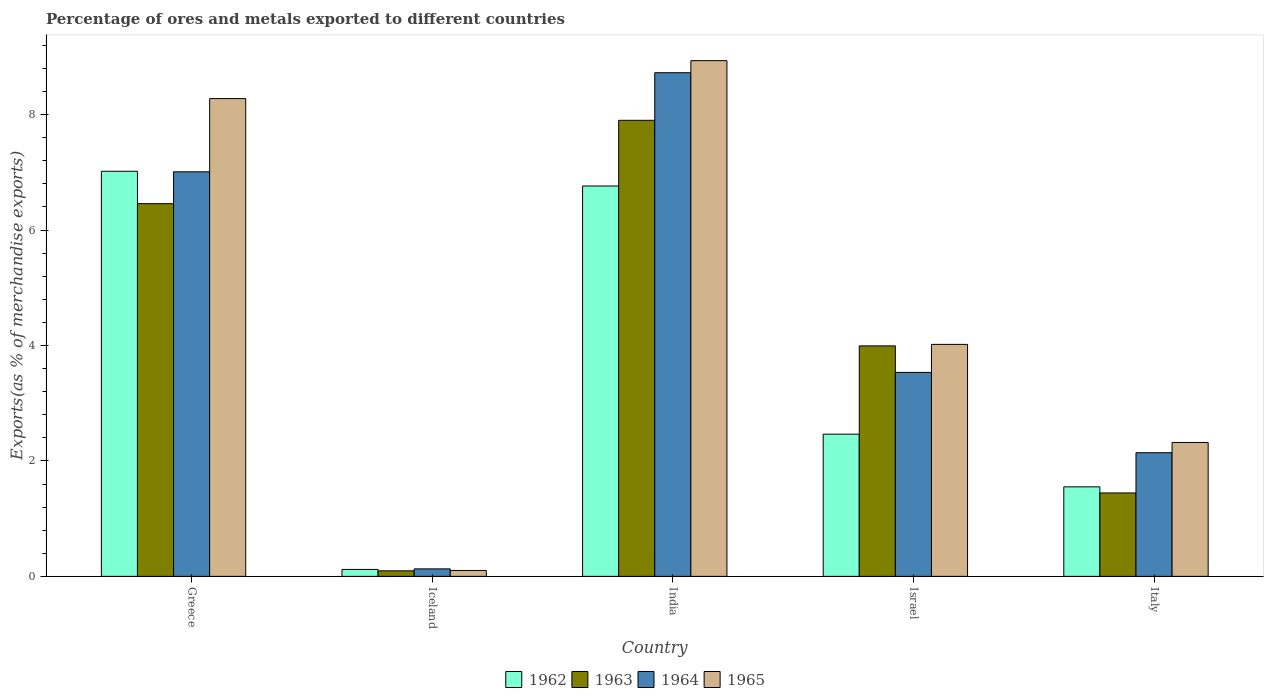How many different coloured bars are there?
Provide a short and direct response. 4. Are the number of bars per tick equal to the number of legend labels?
Your response must be concise. Yes. How many bars are there on the 4th tick from the left?
Your response must be concise. 4. How many bars are there on the 3rd tick from the right?
Offer a very short reply. 4. What is the label of the 1st group of bars from the left?
Offer a terse response. Greece. What is the percentage of exports to different countries in 1962 in Greece?
Offer a very short reply. 7.02. Across all countries, what is the maximum percentage of exports to different countries in 1965?
Make the answer very short. 8.94. Across all countries, what is the minimum percentage of exports to different countries in 1962?
Your response must be concise. 0.12. In which country was the percentage of exports to different countries in 1963 minimum?
Provide a succinct answer. Iceland. What is the total percentage of exports to different countries in 1964 in the graph?
Keep it short and to the point. 21.54. What is the difference between the percentage of exports to different countries in 1963 in Iceland and that in Israel?
Make the answer very short. -3.9. What is the difference between the percentage of exports to different countries in 1963 in Iceland and the percentage of exports to different countries in 1964 in Greece?
Your response must be concise. -6.91. What is the average percentage of exports to different countries in 1963 per country?
Offer a terse response. 3.98. What is the difference between the percentage of exports to different countries of/in 1963 and percentage of exports to different countries of/in 1965 in India?
Make the answer very short. -1.03. What is the ratio of the percentage of exports to different countries in 1962 in India to that in Italy?
Provide a succinct answer. 4.36. Is the percentage of exports to different countries in 1962 in Iceland less than that in Italy?
Offer a terse response. Yes. Is the difference between the percentage of exports to different countries in 1963 in Greece and Israel greater than the difference between the percentage of exports to different countries in 1965 in Greece and Israel?
Your answer should be very brief. No. What is the difference between the highest and the second highest percentage of exports to different countries in 1962?
Offer a very short reply. -4.3. What is the difference between the highest and the lowest percentage of exports to different countries in 1964?
Your answer should be compact. 8.6. Is the sum of the percentage of exports to different countries in 1963 in India and Italy greater than the maximum percentage of exports to different countries in 1965 across all countries?
Ensure brevity in your answer.  Yes. Is it the case that in every country, the sum of the percentage of exports to different countries in 1963 and percentage of exports to different countries in 1964 is greater than the sum of percentage of exports to different countries in 1962 and percentage of exports to different countries in 1965?
Offer a terse response. No. What does the 2nd bar from the right in Iceland represents?
Your response must be concise. 1964. How many bars are there?
Provide a short and direct response. 20. Are the values on the major ticks of Y-axis written in scientific E-notation?
Ensure brevity in your answer.  No. Where does the legend appear in the graph?
Your response must be concise. Bottom center. How many legend labels are there?
Your response must be concise. 4. What is the title of the graph?
Your answer should be compact. Percentage of ores and metals exported to different countries. Does "1964" appear as one of the legend labels in the graph?
Your answer should be compact. Yes. What is the label or title of the Y-axis?
Offer a very short reply. Exports(as % of merchandise exports). What is the Exports(as % of merchandise exports) of 1962 in Greece?
Your response must be concise. 7.02. What is the Exports(as % of merchandise exports) of 1963 in Greece?
Your response must be concise. 6.46. What is the Exports(as % of merchandise exports) of 1964 in Greece?
Offer a terse response. 7.01. What is the Exports(as % of merchandise exports) of 1965 in Greece?
Make the answer very short. 8.28. What is the Exports(as % of merchandise exports) of 1962 in Iceland?
Keep it short and to the point. 0.12. What is the Exports(as % of merchandise exports) of 1963 in Iceland?
Make the answer very short. 0.1. What is the Exports(as % of merchandise exports) of 1964 in Iceland?
Offer a very short reply. 0.13. What is the Exports(as % of merchandise exports) of 1965 in Iceland?
Offer a very short reply. 0.1. What is the Exports(as % of merchandise exports) of 1962 in India?
Provide a succinct answer. 6.76. What is the Exports(as % of merchandise exports) in 1963 in India?
Keep it short and to the point. 7.9. What is the Exports(as % of merchandise exports) in 1964 in India?
Keep it short and to the point. 8.73. What is the Exports(as % of merchandise exports) of 1965 in India?
Offer a terse response. 8.94. What is the Exports(as % of merchandise exports) in 1962 in Israel?
Provide a short and direct response. 2.46. What is the Exports(as % of merchandise exports) of 1963 in Israel?
Give a very brief answer. 3.99. What is the Exports(as % of merchandise exports) in 1964 in Israel?
Offer a very short reply. 3.53. What is the Exports(as % of merchandise exports) in 1965 in Israel?
Ensure brevity in your answer.  4.02. What is the Exports(as % of merchandise exports) of 1962 in Italy?
Offer a terse response. 1.55. What is the Exports(as % of merchandise exports) in 1963 in Italy?
Ensure brevity in your answer.  1.45. What is the Exports(as % of merchandise exports) in 1964 in Italy?
Your answer should be very brief. 2.14. What is the Exports(as % of merchandise exports) of 1965 in Italy?
Your answer should be very brief. 2.32. Across all countries, what is the maximum Exports(as % of merchandise exports) of 1962?
Provide a succinct answer. 7.02. Across all countries, what is the maximum Exports(as % of merchandise exports) of 1963?
Keep it short and to the point. 7.9. Across all countries, what is the maximum Exports(as % of merchandise exports) of 1964?
Provide a succinct answer. 8.73. Across all countries, what is the maximum Exports(as % of merchandise exports) of 1965?
Provide a short and direct response. 8.94. Across all countries, what is the minimum Exports(as % of merchandise exports) of 1962?
Provide a succinct answer. 0.12. Across all countries, what is the minimum Exports(as % of merchandise exports) in 1963?
Provide a succinct answer. 0.1. Across all countries, what is the minimum Exports(as % of merchandise exports) in 1964?
Offer a terse response. 0.13. Across all countries, what is the minimum Exports(as % of merchandise exports) of 1965?
Give a very brief answer. 0.1. What is the total Exports(as % of merchandise exports) of 1962 in the graph?
Your answer should be very brief. 17.92. What is the total Exports(as % of merchandise exports) of 1963 in the graph?
Ensure brevity in your answer.  19.89. What is the total Exports(as % of merchandise exports) of 1964 in the graph?
Give a very brief answer. 21.54. What is the total Exports(as % of merchandise exports) of 1965 in the graph?
Your answer should be very brief. 23.65. What is the difference between the Exports(as % of merchandise exports) of 1962 in Greece and that in Iceland?
Offer a terse response. 6.9. What is the difference between the Exports(as % of merchandise exports) in 1963 in Greece and that in Iceland?
Your response must be concise. 6.36. What is the difference between the Exports(as % of merchandise exports) of 1964 in Greece and that in Iceland?
Offer a terse response. 6.88. What is the difference between the Exports(as % of merchandise exports) in 1965 in Greece and that in Iceland?
Your answer should be very brief. 8.18. What is the difference between the Exports(as % of merchandise exports) in 1962 in Greece and that in India?
Keep it short and to the point. 0.26. What is the difference between the Exports(as % of merchandise exports) in 1963 in Greece and that in India?
Provide a succinct answer. -1.44. What is the difference between the Exports(as % of merchandise exports) of 1964 in Greece and that in India?
Ensure brevity in your answer.  -1.72. What is the difference between the Exports(as % of merchandise exports) of 1965 in Greece and that in India?
Make the answer very short. -0.66. What is the difference between the Exports(as % of merchandise exports) of 1962 in Greece and that in Israel?
Ensure brevity in your answer.  4.55. What is the difference between the Exports(as % of merchandise exports) of 1963 in Greece and that in Israel?
Ensure brevity in your answer.  2.46. What is the difference between the Exports(as % of merchandise exports) of 1964 in Greece and that in Israel?
Keep it short and to the point. 3.48. What is the difference between the Exports(as % of merchandise exports) of 1965 in Greece and that in Israel?
Ensure brevity in your answer.  4.26. What is the difference between the Exports(as % of merchandise exports) of 1962 in Greece and that in Italy?
Ensure brevity in your answer.  5.47. What is the difference between the Exports(as % of merchandise exports) in 1963 in Greece and that in Italy?
Offer a terse response. 5.01. What is the difference between the Exports(as % of merchandise exports) in 1964 in Greece and that in Italy?
Give a very brief answer. 4.87. What is the difference between the Exports(as % of merchandise exports) of 1965 in Greece and that in Italy?
Make the answer very short. 5.96. What is the difference between the Exports(as % of merchandise exports) of 1962 in Iceland and that in India?
Make the answer very short. -6.64. What is the difference between the Exports(as % of merchandise exports) of 1963 in Iceland and that in India?
Offer a very short reply. -7.81. What is the difference between the Exports(as % of merchandise exports) of 1964 in Iceland and that in India?
Offer a very short reply. -8.6. What is the difference between the Exports(as % of merchandise exports) in 1965 in Iceland and that in India?
Provide a succinct answer. -8.83. What is the difference between the Exports(as % of merchandise exports) of 1962 in Iceland and that in Israel?
Provide a short and direct response. -2.34. What is the difference between the Exports(as % of merchandise exports) of 1963 in Iceland and that in Israel?
Offer a very short reply. -3.9. What is the difference between the Exports(as % of merchandise exports) of 1964 in Iceland and that in Israel?
Offer a very short reply. -3.4. What is the difference between the Exports(as % of merchandise exports) in 1965 in Iceland and that in Israel?
Provide a short and direct response. -3.92. What is the difference between the Exports(as % of merchandise exports) of 1962 in Iceland and that in Italy?
Your answer should be very brief. -1.43. What is the difference between the Exports(as % of merchandise exports) in 1963 in Iceland and that in Italy?
Provide a succinct answer. -1.35. What is the difference between the Exports(as % of merchandise exports) in 1964 in Iceland and that in Italy?
Offer a very short reply. -2.01. What is the difference between the Exports(as % of merchandise exports) in 1965 in Iceland and that in Italy?
Your answer should be very brief. -2.22. What is the difference between the Exports(as % of merchandise exports) of 1962 in India and that in Israel?
Your answer should be very brief. 4.3. What is the difference between the Exports(as % of merchandise exports) of 1963 in India and that in Israel?
Give a very brief answer. 3.91. What is the difference between the Exports(as % of merchandise exports) of 1964 in India and that in Israel?
Offer a terse response. 5.19. What is the difference between the Exports(as % of merchandise exports) of 1965 in India and that in Israel?
Ensure brevity in your answer.  4.92. What is the difference between the Exports(as % of merchandise exports) in 1962 in India and that in Italy?
Ensure brevity in your answer.  5.21. What is the difference between the Exports(as % of merchandise exports) of 1963 in India and that in Italy?
Your answer should be compact. 6.46. What is the difference between the Exports(as % of merchandise exports) in 1964 in India and that in Italy?
Your response must be concise. 6.58. What is the difference between the Exports(as % of merchandise exports) of 1965 in India and that in Italy?
Your answer should be very brief. 6.62. What is the difference between the Exports(as % of merchandise exports) of 1962 in Israel and that in Italy?
Give a very brief answer. 0.91. What is the difference between the Exports(as % of merchandise exports) in 1963 in Israel and that in Italy?
Make the answer very short. 2.55. What is the difference between the Exports(as % of merchandise exports) of 1964 in Israel and that in Italy?
Your response must be concise. 1.39. What is the difference between the Exports(as % of merchandise exports) of 1965 in Israel and that in Italy?
Provide a short and direct response. 1.7. What is the difference between the Exports(as % of merchandise exports) of 1962 in Greece and the Exports(as % of merchandise exports) of 1963 in Iceland?
Provide a short and direct response. 6.92. What is the difference between the Exports(as % of merchandise exports) of 1962 in Greece and the Exports(as % of merchandise exports) of 1964 in Iceland?
Your answer should be very brief. 6.89. What is the difference between the Exports(as % of merchandise exports) in 1962 in Greece and the Exports(as % of merchandise exports) in 1965 in Iceland?
Give a very brief answer. 6.92. What is the difference between the Exports(as % of merchandise exports) in 1963 in Greece and the Exports(as % of merchandise exports) in 1964 in Iceland?
Keep it short and to the point. 6.33. What is the difference between the Exports(as % of merchandise exports) of 1963 in Greece and the Exports(as % of merchandise exports) of 1965 in Iceland?
Your response must be concise. 6.36. What is the difference between the Exports(as % of merchandise exports) of 1964 in Greece and the Exports(as % of merchandise exports) of 1965 in Iceland?
Provide a succinct answer. 6.91. What is the difference between the Exports(as % of merchandise exports) in 1962 in Greece and the Exports(as % of merchandise exports) in 1963 in India?
Give a very brief answer. -0.88. What is the difference between the Exports(as % of merchandise exports) of 1962 in Greece and the Exports(as % of merchandise exports) of 1964 in India?
Ensure brevity in your answer.  -1.71. What is the difference between the Exports(as % of merchandise exports) in 1962 in Greece and the Exports(as % of merchandise exports) in 1965 in India?
Ensure brevity in your answer.  -1.92. What is the difference between the Exports(as % of merchandise exports) in 1963 in Greece and the Exports(as % of merchandise exports) in 1964 in India?
Your answer should be compact. -2.27. What is the difference between the Exports(as % of merchandise exports) in 1963 in Greece and the Exports(as % of merchandise exports) in 1965 in India?
Your answer should be very brief. -2.48. What is the difference between the Exports(as % of merchandise exports) of 1964 in Greece and the Exports(as % of merchandise exports) of 1965 in India?
Keep it short and to the point. -1.93. What is the difference between the Exports(as % of merchandise exports) in 1962 in Greece and the Exports(as % of merchandise exports) in 1963 in Israel?
Provide a short and direct response. 3.03. What is the difference between the Exports(as % of merchandise exports) in 1962 in Greece and the Exports(as % of merchandise exports) in 1964 in Israel?
Provide a short and direct response. 3.48. What is the difference between the Exports(as % of merchandise exports) in 1962 in Greece and the Exports(as % of merchandise exports) in 1965 in Israel?
Your answer should be compact. 3. What is the difference between the Exports(as % of merchandise exports) in 1963 in Greece and the Exports(as % of merchandise exports) in 1964 in Israel?
Make the answer very short. 2.92. What is the difference between the Exports(as % of merchandise exports) of 1963 in Greece and the Exports(as % of merchandise exports) of 1965 in Israel?
Your answer should be compact. 2.44. What is the difference between the Exports(as % of merchandise exports) of 1964 in Greece and the Exports(as % of merchandise exports) of 1965 in Israel?
Ensure brevity in your answer.  2.99. What is the difference between the Exports(as % of merchandise exports) of 1962 in Greece and the Exports(as % of merchandise exports) of 1963 in Italy?
Ensure brevity in your answer.  5.57. What is the difference between the Exports(as % of merchandise exports) in 1962 in Greece and the Exports(as % of merchandise exports) in 1964 in Italy?
Provide a succinct answer. 4.88. What is the difference between the Exports(as % of merchandise exports) in 1962 in Greece and the Exports(as % of merchandise exports) in 1965 in Italy?
Make the answer very short. 4.7. What is the difference between the Exports(as % of merchandise exports) of 1963 in Greece and the Exports(as % of merchandise exports) of 1964 in Italy?
Your answer should be compact. 4.32. What is the difference between the Exports(as % of merchandise exports) in 1963 in Greece and the Exports(as % of merchandise exports) in 1965 in Italy?
Your answer should be compact. 4.14. What is the difference between the Exports(as % of merchandise exports) of 1964 in Greece and the Exports(as % of merchandise exports) of 1965 in Italy?
Offer a terse response. 4.69. What is the difference between the Exports(as % of merchandise exports) of 1962 in Iceland and the Exports(as % of merchandise exports) of 1963 in India?
Give a very brief answer. -7.78. What is the difference between the Exports(as % of merchandise exports) of 1962 in Iceland and the Exports(as % of merchandise exports) of 1964 in India?
Provide a short and direct response. -8.61. What is the difference between the Exports(as % of merchandise exports) of 1962 in Iceland and the Exports(as % of merchandise exports) of 1965 in India?
Make the answer very short. -8.82. What is the difference between the Exports(as % of merchandise exports) of 1963 in Iceland and the Exports(as % of merchandise exports) of 1964 in India?
Your answer should be very brief. -8.63. What is the difference between the Exports(as % of merchandise exports) of 1963 in Iceland and the Exports(as % of merchandise exports) of 1965 in India?
Provide a short and direct response. -8.84. What is the difference between the Exports(as % of merchandise exports) in 1964 in Iceland and the Exports(as % of merchandise exports) in 1965 in India?
Your answer should be very brief. -8.81. What is the difference between the Exports(as % of merchandise exports) in 1962 in Iceland and the Exports(as % of merchandise exports) in 1963 in Israel?
Give a very brief answer. -3.87. What is the difference between the Exports(as % of merchandise exports) of 1962 in Iceland and the Exports(as % of merchandise exports) of 1964 in Israel?
Offer a very short reply. -3.41. What is the difference between the Exports(as % of merchandise exports) in 1962 in Iceland and the Exports(as % of merchandise exports) in 1965 in Israel?
Ensure brevity in your answer.  -3.9. What is the difference between the Exports(as % of merchandise exports) in 1963 in Iceland and the Exports(as % of merchandise exports) in 1964 in Israel?
Give a very brief answer. -3.44. What is the difference between the Exports(as % of merchandise exports) of 1963 in Iceland and the Exports(as % of merchandise exports) of 1965 in Israel?
Provide a short and direct response. -3.92. What is the difference between the Exports(as % of merchandise exports) of 1964 in Iceland and the Exports(as % of merchandise exports) of 1965 in Israel?
Make the answer very short. -3.89. What is the difference between the Exports(as % of merchandise exports) in 1962 in Iceland and the Exports(as % of merchandise exports) in 1963 in Italy?
Keep it short and to the point. -1.33. What is the difference between the Exports(as % of merchandise exports) in 1962 in Iceland and the Exports(as % of merchandise exports) in 1964 in Italy?
Your answer should be compact. -2.02. What is the difference between the Exports(as % of merchandise exports) in 1962 in Iceland and the Exports(as % of merchandise exports) in 1965 in Italy?
Provide a succinct answer. -2.2. What is the difference between the Exports(as % of merchandise exports) in 1963 in Iceland and the Exports(as % of merchandise exports) in 1964 in Italy?
Make the answer very short. -2.05. What is the difference between the Exports(as % of merchandise exports) in 1963 in Iceland and the Exports(as % of merchandise exports) in 1965 in Italy?
Keep it short and to the point. -2.22. What is the difference between the Exports(as % of merchandise exports) of 1964 in Iceland and the Exports(as % of merchandise exports) of 1965 in Italy?
Your answer should be compact. -2.19. What is the difference between the Exports(as % of merchandise exports) of 1962 in India and the Exports(as % of merchandise exports) of 1963 in Israel?
Give a very brief answer. 2.77. What is the difference between the Exports(as % of merchandise exports) in 1962 in India and the Exports(as % of merchandise exports) in 1964 in Israel?
Provide a short and direct response. 3.23. What is the difference between the Exports(as % of merchandise exports) of 1962 in India and the Exports(as % of merchandise exports) of 1965 in Israel?
Give a very brief answer. 2.74. What is the difference between the Exports(as % of merchandise exports) of 1963 in India and the Exports(as % of merchandise exports) of 1964 in Israel?
Make the answer very short. 4.37. What is the difference between the Exports(as % of merchandise exports) of 1963 in India and the Exports(as % of merchandise exports) of 1965 in Israel?
Provide a succinct answer. 3.88. What is the difference between the Exports(as % of merchandise exports) in 1964 in India and the Exports(as % of merchandise exports) in 1965 in Israel?
Provide a succinct answer. 4.71. What is the difference between the Exports(as % of merchandise exports) of 1962 in India and the Exports(as % of merchandise exports) of 1963 in Italy?
Provide a short and direct response. 5.32. What is the difference between the Exports(as % of merchandise exports) in 1962 in India and the Exports(as % of merchandise exports) in 1964 in Italy?
Offer a terse response. 4.62. What is the difference between the Exports(as % of merchandise exports) of 1962 in India and the Exports(as % of merchandise exports) of 1965 in Italy?
Provide a short and direct response. 4.44. What is the difference between the Exports(as % of merchandise exports) in 1963 in India and the Exports(as % of merchandise exports) in 1964 in Italy?
Offer a terse response. 5.76. What is the difference between the Exports(as % of merchandise exports) in 1963 in India and the Exports(as % of merchandise exports) in 1965 in Italy?
Make the answer very short. 5.58. What is the difference between the Exports(as % of merchandise exports) in 1964 in India and the Exports(as % of merchandise exports) in 1965 in Italy?
Ensure brevity in your answer.  6.41. What is the difference between the Exports(as % of merchandise exports) of 1962 in Israel and the Exports(as % of merchandise exports) of 1963 in Italy?
Give a very brief answer. 1.02. What is the difference between the Exports(as % of merchandise exports) in 1962 in Israel and the Exports(as % of merchandise exports) in 1964 in Italy?
Your answer should be very brief. 0.32. What is the difference between the Exports(as % of merchandise exports) in 1962 in Israel and the Exports(as % of merchandise exports) in 1965 in Italy?
Give a very brief answer. 0.14. What is the difference between the Exports(as % of merchandise exports) of 1963 in Israel and the Exports(as % of merchandise exports) of 1964 in Italy?
Your answer should be very brief. 1.85. What is the difference between the Exports(as % of merchandise exports) of 1963 in Israel and the Exports(as % of merchandise exports) of 1965 in Italy?
Give a very brief answer. 1.67. What is the difference between the Exports(as % of merchandise exports) in 1964 in Israel and the Exports(as % of merchandise exports) in 1965 in Italy?
Offer a terse response. 1.21. What is the average Exports(as % of merchandise exports) of 1962 per country?
Make the answer very short. 3.58. What is the average Exports(as % of merchandise exports) of 1963 per country?
Provide a short and direct response. 3.98. What is the average Exports(as % of merchandise exports) of 1964 per country?
Your response must be concise. 4.31. What is the average Exports(as % of merchandise exports) of 1965 per country?
Offer a terse response. 4.73. What is the difference between the Exports(as % of merchandise exports) of 1962 and Exports(as % of merchandise exports) of 1963 in Greece?
Give a very brief answer. 0.56. What is the difference between the Exports(as % of merchandise exports) of 1962 and Exports(as % of merchandise exports) of 1964 in Greece?
Your answer should be very brief. 0.01. What is the difference between the Exports(as % of merchandise exports) of 1962 and Exports(as % of merchandise exports) of 1965 in Greece?
Provide a succinct answer. -1.26. What is the difference between the Exports(as % of merchandise exports) in 1963 and Exports(as % of merchandise exports) in 1964 in Greece?
Your answer should be compact. -0.55. What is the difference between the Exports(as % of merchandise exports) of 1963 and Exports(as % of merchandise exports) of 1965 in Greece?
Your response must be concise. -1.82. What is the difference between the Exports(as % of merchandise exports) in 1964 and Exports(as % of merchandise exports) in 1965 in Greece?
Your answer should be very brief. -1.27. What is the difference between the Exports(as % of merchandise exports) in 1962 and Exports(as % of merchandise exports) in 1963 in Iceland?
Your response must be concise. 0.02. What is the difference between the Exports(as % of merchandise exports) in 1962 and Exports(as % of merchandise exports) in 1964 in Iceland?
Ensure brevity in your answer.  -0.01. What is the difference between the Exports(as % of merchandise exports) in 1962 and Exports(as % of merchandise exports) in 1965 in Iceland?
Make the answer very short. 0.02. What is the difference between the Exports(as % of merchandise exports) in 1963 and Exports(as % of merchandise exports) in 1964 in Iceland?
Your answer should be very brief. -0.03. What is the difference between the Exports(as % of merchandise exports) in 1963 and Exports(as % of merchandise exports) in 1965 in Iceland?
Provide a succinct answer. -0.01. What is the difference between the Exports(as % of merchandise exports) in 1964 and Exports(as % of merchandise exports) in 1965 in Iceland?
Offer a terse response. 0.03. What is the difference between the Exports(as % of merchandise exports) of 1962 and Exports(as % of merchandise exports) of 1963 in India?
Give a very brief answer. -1.14. What is the difference between the Exports(as % of merchandise exports) of 1962 and Exports(as % of merchandise exports) of 1964 in India?
Make the answer very short. -1.96. What is the difference between the Exports(as % of merchandise exports) of 1962 and Exports(as % of merchandise exports) of 1965 in India?
Offer a terse response. -2.17. What is the difference between the Exports(as % of merchandise exports) in 1963 and Exports(as % of merchandise exports) in 1964 in India?
Keep it short and to the point. -0.82. What is the difference between the Exports(as % of merchandise exports) of 1963 and Exports(as % of merchandise exports) of 1965 in India?
Ensure brevity in your answer.  -1.03. What is the difference between the Exports(as % of merchandise exports) in 1964 and Exports(as % of merchandise exports) in 1965 in India?
Ensure brevity in your answer.  -0.21. What is the difference between the Exports(as % of merchandise exports) in 1962 and Exports(as % of merchandise exports) in 1963 in Israel?
Make the answer very short. -1.53. What is the difference between the Exports(as % of merchandise exports) of 1962 and Exports(as % of merchandise exports) of 1964 in Israel?
Keep it short and to the point. -1.07. What is the difference between the Exports(as % of merchandise exports) of 1962 and Exports(as % of merchandise exports) of 1965 in Israel?
Offer a very short reply. -1.56. What is the difference between the Exports(as % of merchandise exports) in 1963 and Exports(as % of merchandise exports) in 1964 in Israel?
Make the answer very short. 0.46. What is the difference between the Exports(as % of merchandise exports) in 1963 and Exports(as % of merchandise exports) in 1965 in Israel?
Offer a very short reply. -0.03. What is the difference between the Exports(as % of merchandise exports) in 1964 and Exports(as % of merchandise exports) in 1965 in Israel?
Make the answer very short. -0.49. What is the difference between the Exports(as % of merchandise exports) in 1962 and Exports(as % of merchandise exports) in 1963 in Italy?
Offer a very short reply. 0.11. What is the difference between the Exports(as % of merchandise exports) in 1962 and Exports(as % of merchandise exports) in 1964 in Italy?
Provide a succinct answer. -0.59. What is the difference between the Exports(as % of merchandise exports) of 1962 and Exports(as % of merchandise exports) of 1965 in Italy?
Your answer should be compact. -0.77. What is the difference between the Exports(as % of merchandise exports) in 1963 and Exports(as % of merchandise exports) in 1964 in Italy?
Offer a very short reply. -0.7. What is the difference between the Exports(as % of merchandise exports) in 1963 and Exports(as % of merchandise exports) in 1965 in Italy?
Offer a very short reply. -0.87. What is the difference between the Exports(as % of merchandise exports) in 1964 and Exports(as % of merchandise exports) in 1965 in Italy?
Offer a terse response. -0.18. What is the ratio of the Exports(as % of merchandise exports) in 1962 in Greece to that in Iceland?
Your response must be concise. 58.51. What is the ratio of the Exports(as % of merchandise exports) in 1963 in Greece to that in Iceland?
Make the answer very short. 67.38. What is the ratio of the Exports(as % of merchandise exports) of 1964 in Greece to that in Iceland?
Ensure brevity in your answer.  54.09. What is the ratio of the Exports(as % of merchandise exports) in 1965 in Greece to that in Iceland?
Your answer should be compact. 81.09. What is the ratio of the Exports(as % of merchandise exports) of 1962 in Greece to that in India?
Ensure brevity in your answer.  1.04. What is the ratio of the Exports(as % of merchandise exports) of 1963 in Greece to that in India?
Your answer should be compact. 0.82. What is the ratio of the Exports(as % of merchandise exports) in 1964 in Greece to that in India?
Keep it short and to the point. 0.8. What is the ratio of the Exports(as % of merchandise exports) of 1965 in Greece to that in India?
Offer a very short reply. 0.93. What is the ratio of the Exports(as % of merchandise exports) of 1962 in Greece to that in Israel?
Give a very brief answer. 2.85. What is the ratio of the Exports(as % of merchandise exports) of 1963 in Greece to that in Israel?
Your answer should be very brief. 1.62. What is the ratio of the Exports(as % of merchandise exports) of 1964 in Greece to that in Israel?
Provide a succinct answer. 1.98. What is the ratio of the Exports(as % of merchandise exports) in 1965 in Greece to that in Israel?
Offer a terse response. 2.06. What is the ratio of the Exports(as % of merchandise exports) in 1962 in Greece to that in Italy?
Your response must be concise. 4.53. What is the ratio of the Exports(as % of merchandise exports) in 1963 in Greece to that in Italy?
Your response must be concise. 4.47. What is the ratio of the Exports(as % of merchandise exports) in 1964 in Greece to that in Italy?
Make the answer very short. 3.27. What is the ratio of the Exports(as % of merchandise exports) in 1965 in Greece to that in Italy?
Offer a terse response. 3.57. What is the ratio of the Exports(as % of merchandise exports) of 1962 in Iceland to that in India?
Offer a terse response. 0.02. What is the ratio of the Exports(as % of merchandise exports) in 1963 in Iceland to that in India?
Your response must be concise. 0.01. What is the ratio of the Exports(as % of merchandise exports) in 1964 in Iceland to that in India?
Provide a short and direct response. 0.01. What is the ratio of the Exports(as % of merchandise exports) of 1965 in Iceland to that in India?
Offer a very short reply. 0.01. What is the ratio of the Exports(as % of merchandise exports) in 1962 in Iceland to that in Israel?
Your answer should be very brief. 0.05. What is the ratio of the Exports(as % of merchandise exports) of 1963 in Iceland to that in Israel?
Ensure brevity in your answer.  0.02. What is the ratio of the Exports(as % of merchandise exports) in 1964 in Iceland to that in Israel?
Provide a succinct answer. 0.04. What is the ratio of the Exports(as % of merchandise exports) of 1965 in Iceland to that in Israel?
Offer a very short reply. 0.03. What is the ratio of the Exports(as % of merchandise exports) in 1962 in Iceland to that in Italy?
Provide a succinct answer. 0.08. What is the ratio of the Exports(as % of merchandise exports) in 1963 in Iceland to that in Italy?
Keep it short and to the point. 0.07. What is the ratio of the Exports(as % of merchandise exports) in 1964 in Iceland to that in Italy?
Give a very brief answer. 0.06. What is the ratio of the Exports(as % of merchandise exports) in 1965 in Iceland to that in Italy?
Ensure brevity in your answer.  0.04. What is the ratio of the Exports(as % of merchandise exports) in 1962 in India to that in Israel?
Provide a short and direct response. 2.75. What is the ratio of the Exports(as % of merchandise exports) of 1963 in India to that in Israel?
Your answer should be very brief. 1.98. What is the ratio of the Exports(as % of merchandise exports) in 1964 in India to that in Israel?
Ensure brevity in your answer.  2.47. What is the ratio of the Exports(as % of merchandise exports) in 1965 in India to that in Israel?
Provide a short and direct response. 2.22. What is the ratio of the Exports(as % of merchandise exports) of 1962 in India to that in Italy?
Give a very brief answer. 4.36. What is the ratio of the Exports(as % of merchandise exports) in 1963 in India to that in Italy?
Your answer should be very brief. 5.47. What is the ratio of the Exports(as % of merchandise exports) in 1964 in India to that in Italy?
Ensure brevity in your answer.  4.07. What is the ratio of the Exports(as % of merchandise exports) of 1965 in India to that in Italy?
Offer a very short reply. 3.85. What is the ratio of the Exports(as % of merchandise exports) of 1962 in Israel to that in Italy?
Offer a very short reply. 1.59. What is the ratio of the Exports(as % of merchandise exports) in 1963 in Israel to that in Italy?
Ensure brevity in your answer.  2.76. What is the ratio of the Exports(as % of merchandise exports) in 1964 in Israel to that in Italy?
Offer a terse response. 1.65. What is the ratio of the Exports(as % of merchandise exports) of 1965 in Israel to that in Italy?
Keep it short and to the point. 1.73. What is the difference between the highest and the second highest Exports(as % of merchandise exports) of 1962?
Make the answer very short. 0.26. What is the difference between the highest and the second highest Exports(as % of merchandise exports) in 1963?
Ensure brevity in your answer.  1.44. What is the difference between the highest and the second highest Exports(as % of merchandise exports) in 1964?
Keep it short and to the point. 1.72. What is the difference between the highest and the second highest Exports(as % of merchandise exports) in 1965?
Provide a succinct answer. 0.66. What is the difference between the highest and the lowest Exports(as % of merchandise exports) of 1962?
Keep it short and to the point. 6.9. What is the difference between the highest and the lowest Exports(as % of merchandise exports) of 1963?
Your answer should be very brief. 7.81. What is the difference between the highest and the lowest Exports(as % of merchandise exports) in 1964?
Your answer should be very brief. 8.6. What is the difference between the highest and the lowest Exports(as % of merchandise exports) in 1965?
Provide a short and direct response. 8.83. 